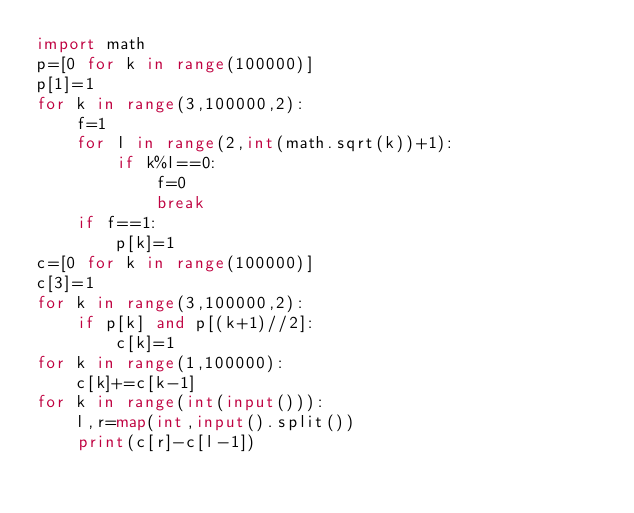<code> <loc_0><loc_0><loc_500><loc_500><_Python_>import math
p=[0 for k in range(100000)]
p[1]=1
for k in range(3,100000,2):
    f=1
    for l in range(2,int(math.sqrt(k))+1):
        if k%l==0:
            f=0
            break
    if f==1:
        p[k]=1
c=[0 for k in range(100000)]
c[3]=1
for k in range(3,100000,2):
    if p[k] and p[(k+1)//2]:
        c[k]=1
for k in range(1,100000):
    c[k]+=c[k-1]
for k in range(int(input())):
    l,r=map(int,input().split())
    print(c[r]-c[l-1])
</code> 